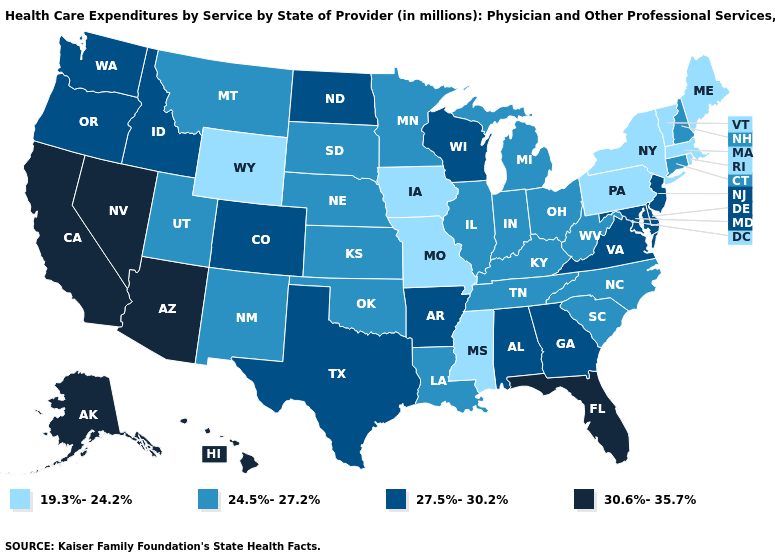Among the states that border Texas , does Oklahoma have the highest value?
Give a very brief answer. No. Which states have the highest value in the USA?
Be succinct. Alaska, Arizona, California, Florida, Hawaii, Nevada. Which states hav the highest value in the MidWest?
Write a very short answer. North Dakota, Wisconsin. What is the value of Alabama?
Quick response, please. 27.5%-30.2%. Name the states that have a value in the range 24.5%-27.2%?
Concise answer only. Connecticut, Illinois, Indiana, Kansas, Kentucky, Louisiana, Michigan, Minnesota, Montana, Nebraska, New Hampshire, New Mexico, North Carolina, Ohio, Oklahoma, South Carolina, South Dakota, Tennessee, Utah, West Virginia. What is the value of Maryland?
Short answer required. 27.5%-30.2%. Does North Dakota have a lower value than South Carolina?
Concise answer only. No. Among the states that border New Mexico , does Utah have the highest value?
Keep it brief. No. What is the lowest value in states that border Florida?
Keep it brief. 27.5%-30.2%. What is the value of Alaska?
Write a very short answer. 30.6%-35.7%. What is the lowest value in states that border Indiana?
Keep it brief. 24.5%-27.2%. What is the lowest value in the MidWest?
Keep it brief. 19.3%-24.2%. Name the states that have a value in the range 30.6%-35.7%?
Write a very short answer. Alaska, Arizona, California, Florida, Hawaii, Nevada. What is the value of Massachusetts?
Keep it brief. 19.3%-24.2%. 